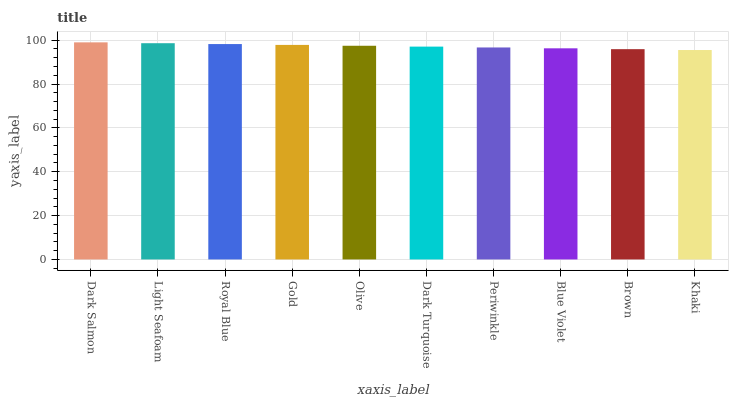Is Light Seafoam the minimum?
Answer yes or no. No. Is Light Seafoam the maximum?
Answer yes or no. No. Is Dark Salmon greater than Light Seafoam?
Answer yes or no. Yes. Is Light Seafoam less than Dark Salmon?
Answer yes or no. Yes. Is Light Seafoam greater than Dark Salmon?
Answer yes or no. No. Is Dark Salmon less than Light Seafoam?
Answer yes or no. No. Is Olive the high median?
Answer yes or no. Yes. Is Dark Turquoise the low median?
Answer yes or no. Yes. Is Khaki the high median?
Answer yes or no. No. Is Blue Violet the low median?
Answer yes or no. No. 